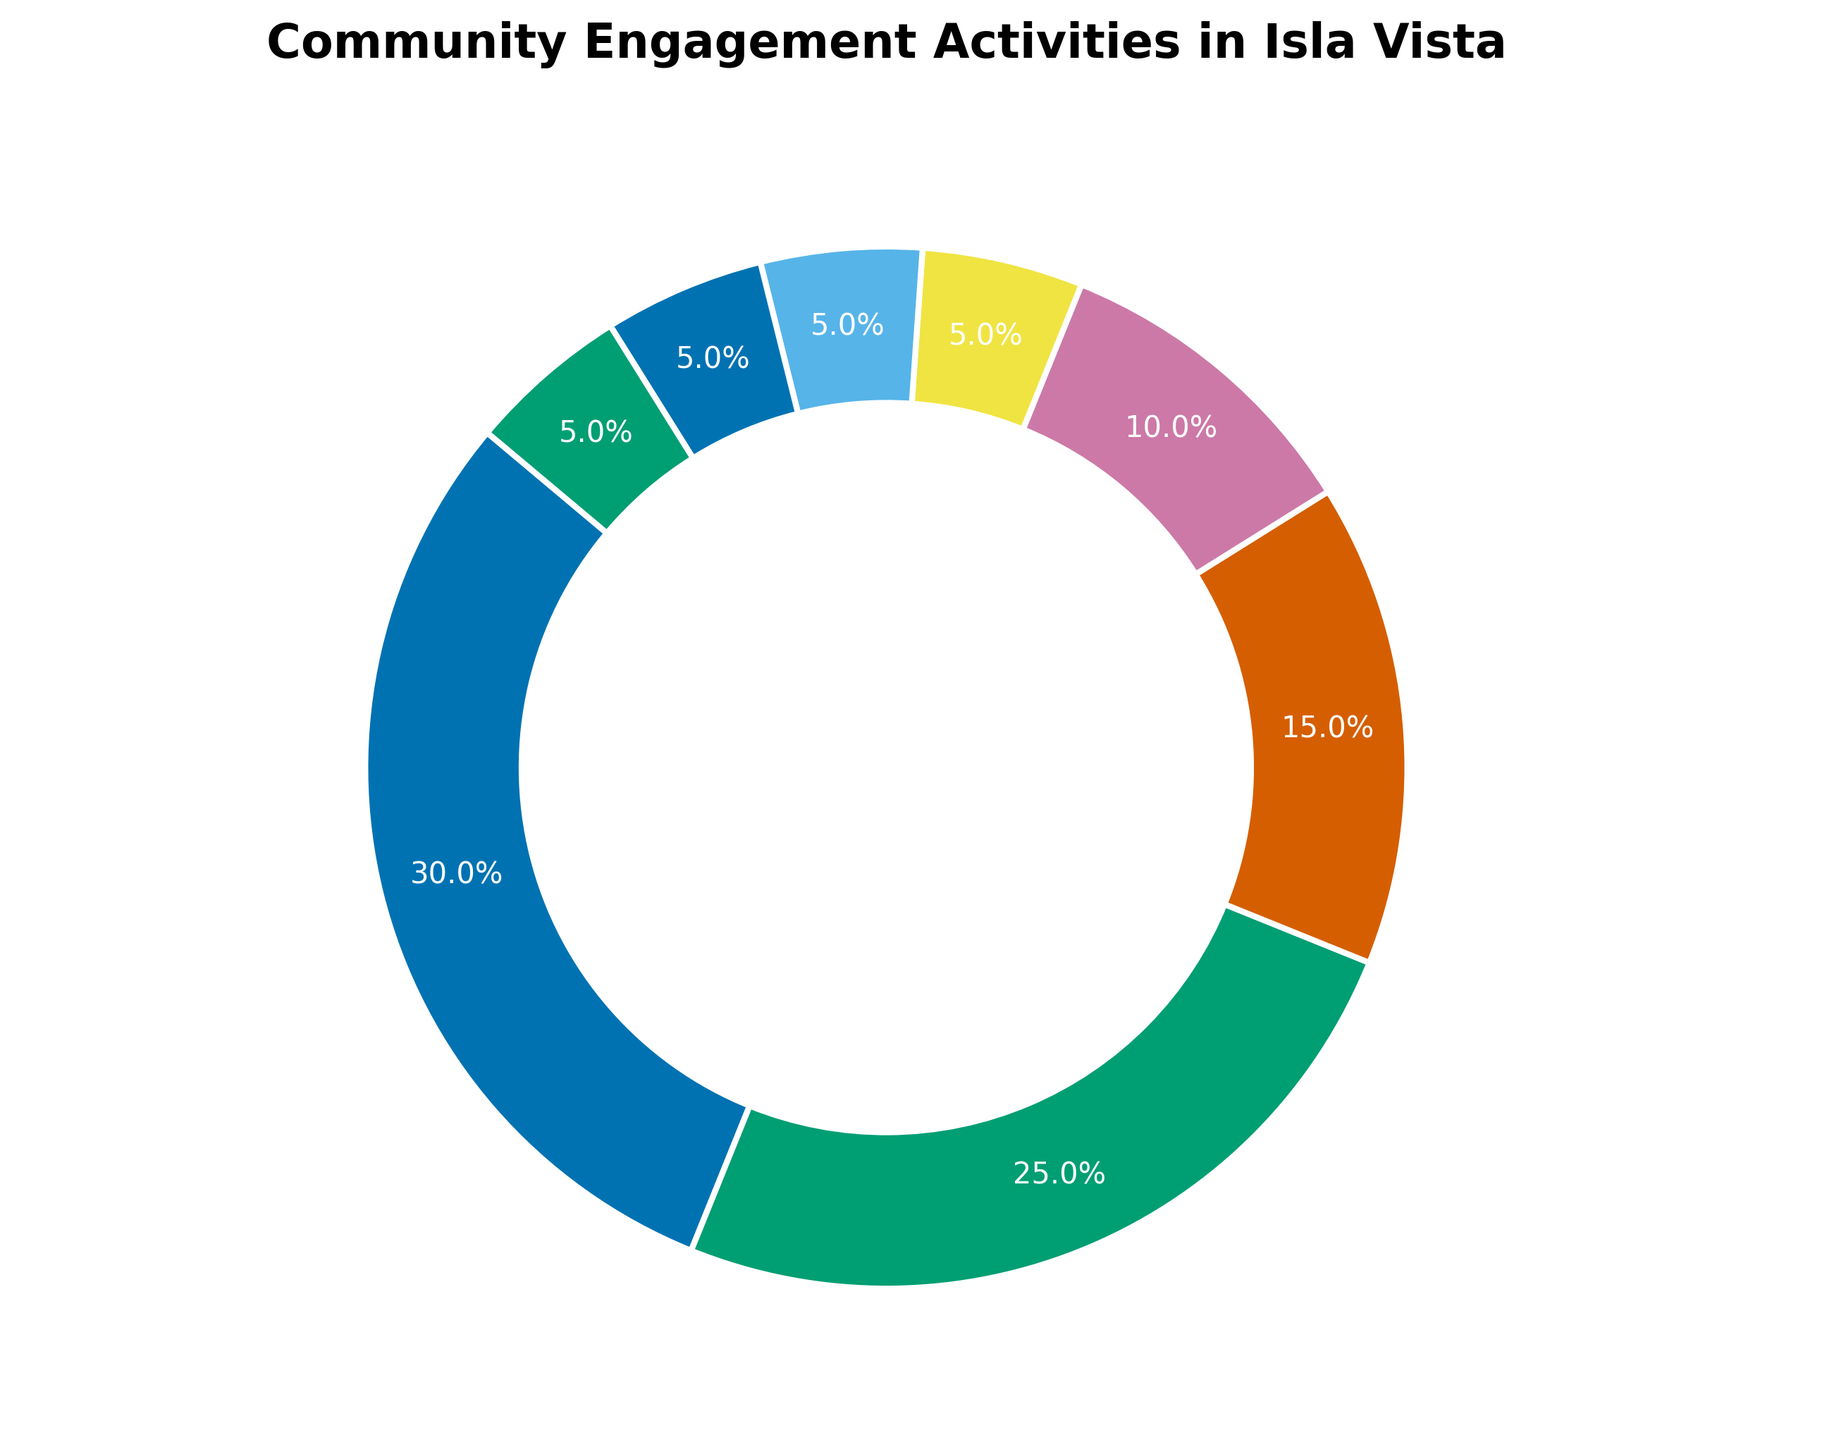Which activity has the highest percentage of community engagement? To determine the activity with the highest percentage, refer to the ring chart and identify the activity occupying the largest segment. The legend or labels will highlight this clearly.
Answer: Volunteer Work How much more percentage does Volunteer Work have compared to Church Events? Find the percentages associated with Volunteer Work and Church Events. Subtract the percentage of Church Events from Volunteer Work. Specifically, 30% - 25%.
Answer: 5% Which activities share the same percentage of community engagement? Look at the segments in the ring chart to see if any activities have identical percentages. The labels will point out this information.
Answer: Environmental Clean-ups, Fundraising Events, Educational Workshops, Neighborhood Meetings What's the combined percentage of all activities except Volunteer Work and Church Events? First, sum up the percentages of Volunteer Work and Church Events, which is 30% + 25% = 55%. Then, subtract this sum from 100%.
Answer: 45% Arrange the activities in ascending order of their engagement percentages. Review the labels associated with each segment in the chart, listing them from the smallest percentage to the largest.
Answer: Environmental Clean-ups, Fundraising Events, Educational Workshops, Neighborhood Meetings, Music and Arts Festivals, Community Sports, Church Events, Volunteer Work What percentage of community engagement is represented by both Environmental Clean-ups and Fundraising Events combined? Identify the percentages of Environmental Clean-ups and Fundraising Events from the ring chart, then add them together: 5% + 5%.
Answer: 10% Which activities have less engagement than Community Sports? Identify activities with percentages lower than that of Community Sports, which has 15%. Refer to the labels on the chart segments.
Answer: Music and Arts Festivals, Environmental Clean-ups, Fundraising Events, Educational Workshops, Neighborhood Meetings What is the third most engaged activity in the community? Rank the activities based on their percentages from highest to lowest. The third rank will be the third highest percentage.
Answer: Community Sports How much of the chart does the Music and Arts Festivals segment occupy visually? Identify the size of the segment corresponding to Music and Arts Festivals by its percentage label: 10%. This represents its visual proportion in the ring chart.
Answer: 10% What is the total percentage represented by Educational Workshops, Neighborhood Meetings, and Environmental Clean-ups combined? Sum the percentages for Educational Workshops, Neighborhood Meetings, and Environmental Clean-ups: 5% + 5% + 5%.
Answer: 15% 